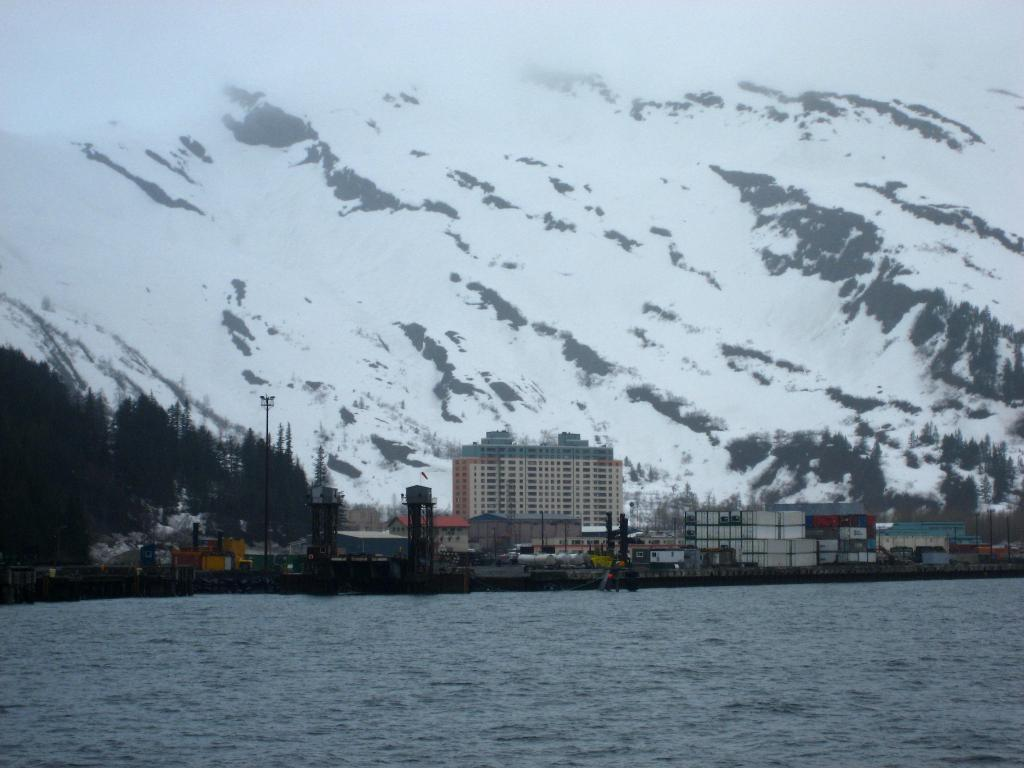What is visible at the bottom of the image? There is water visible at the bottom of the image. What can be seen in the background of the image? In the background of the image, there are trees, poles, metal objects, buildings, houses, and other objects. What is the weather like in the image? Snow is present on the mountains and trees in the background of the image, indicating a cold or snowy environment. Can you see the smile on the cracker in the image? There is no cracker present in the image, and therefore no smile to observe. 